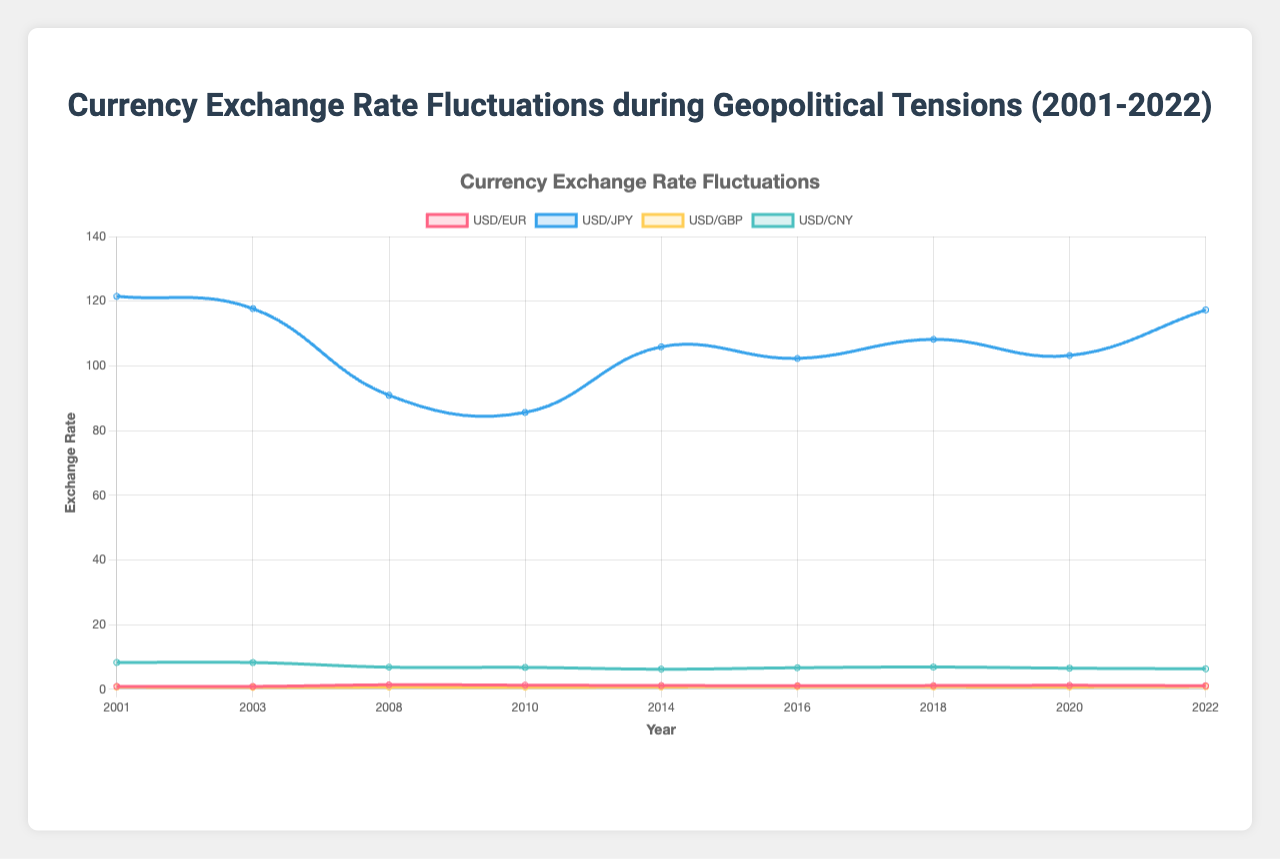What was the exchange rate of USD/EUR in 2008, and how did it compare to 2020? Look at the curve for USD/EUR in 2008, which has a value of 1.39, and in 2020, which has a value of 1.22. Comparing the two, we see that the rate in 2008 was higher.
Answer: 1.39 in 2008; 1.22 in 2020; 2008 was higher How did the USD/JPY exchange rate change from the Global Financial Crisis in 2008 to the Eurozone Debt Crisis in 2010? In 2008, the USD/JPY rate was 90.9. By 2010, it dropped to 85.6. This shows a decline.
Answer: 90.9 to 85.6; decline Which currency pair showed the largest fluctuation between 2001 and 2022? Examine all the currency pairs' starting and ending values. USD/JPY fluctuates from 121.5 in 2001 to 117.3 in 2022, indicating the highest change among the four pairs.
Answer: USD/JPY In which year did USD/EUR reach its highest value? Check the USD/EUR curve for the maximum value, which occurs in 2008 at 1.39.
Answer: 2008 Comparing the USD/GBP values during the Brexit Referendum (2016) and the COVID-19 Pandemic (2020), which year had a higher rate? In 2016, USD/GBP was 0.81, and in 2020, it was 0.74. Therefore, 2016 had a higher rate.
Answer: 2016 What's the overall trend for USD/CNY from 2001 to 2022? Analyze the USD/CNY curve over the years. It starts at 8.28 in 2001 and gradually decreases to 6.33 by 2022, indicating an overall downward trend.
Answer: Downward trend What is the average exchange rate of USD/JPY between 2001 and 2022? Sum of the rates: (121.5 + 117.7 + 90.9 + 85.6 + 105.9 + 102.3 + 108.2 + 103.2 + 117.3) = 952.6. Divided by 9 gives an average of 105.84.
Answer: 105.84 By how much did the USD/GBP exchange rate change during the US-China Trade War (2018)? In 2018, the rate was 0.76. Compare it with the prior year with significant events (2016) at 0.81, resulting in a decrease of 0.05.
Answer: Decreased by 0.05 Which currency was most resistant to fluctuations during the studied geopolitical events? By examining the stability and minimal fluctuation in the data points, USD/CNY remains relatively stable with the smallest changes.
Answer: USD/CNY 